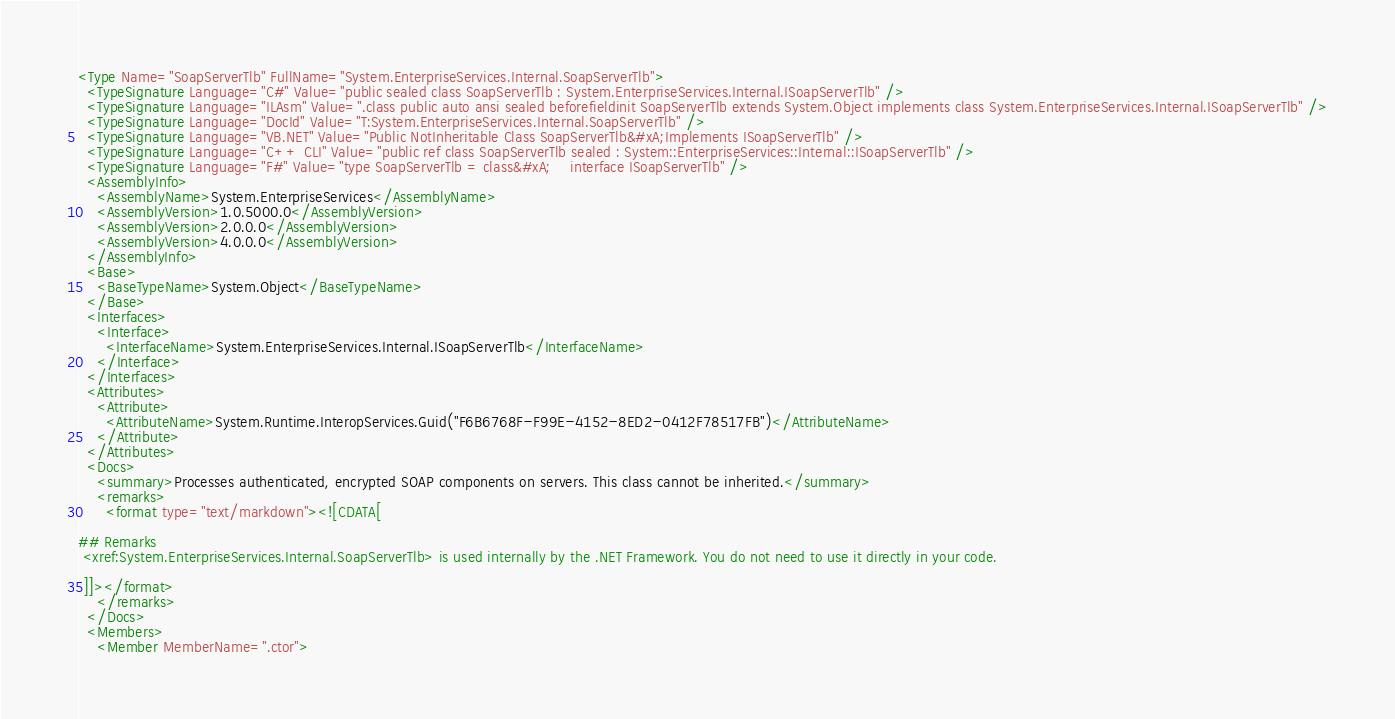<code> <loc_0><loc_0><loc_500><loc_500><_XML_><Type Name="SoapServerTlb" FullName="System.EnterpriseServices.Internal.SoapServerTlb">
  <TypeSignature Language="C#" Value="public sealed class SoapServerTlb : System.EnterpriseServices.Internal.ISoapServerTlb" />
  <TypeSignature Language="ILAsm" Value=".class public auto ansi sealed beforefieldinit SoapServerTlb extends System.Object implements class System.EnterpriseServices.Internal.ISoapServerTlb" />
  <TypeSignature Language="DocId" Value="T:System.EnterpriseServices.Internal.SoapServerTlb" />
  <TypeSignature Language="VB.NET" Value="Public NotInheritable Class SoapServerTlb&#xA;Implements ISoapServerTlb" />
  <TypeSignature Language="C++ CLI" Value="public ref class SoapServerTlb sealed : System::EnterpriseServices::Internal::ISoapServerTlb" />
  <TypeSignature Language="F#" Value="type SoapServerTlb = class&#xA;    interface ISoapServerTlb" />
  <AssemblyInfo>
    <AssemblyName>System.EnterpriseServices</AssemblyName>
    <AssemblyVersion>1.0.5000.0</AssemblyVersion>
    <AssemblyVersion>2.0.0.0</AssemblyVersion>
    <AssemblyVersion>4.0.0.0</AssemblyVersion>
  </AssemblyInfo>
  <Base>
    <BaseTypeName>System.Object</BaseTypeName>
  </Base>
  <Interfaces>
    <Interface>
      <InterfaceName>System.EnterpriseServices.Internal.ISoapServerTlb</InterfaceName>
    </Interface>
  </Interfaces>
  <Attributes>
    <Attribute>
      <AttributeName>System.Runtime.InteropServices.Guid("F6B6768F-F99E-4152-8ED2-0412F78517FB")</AttributeName>
    </Attribute>
  </Attributes>
  <Docs>
    <summary>Processes authenticated, encrypted SOAP components on servers. This class cannot be inherited.</summary>
    <remarks>
      <format type="text/markdown"><![CDATA[  
  
## Remarks  
 <xref:System.EnterpriseServices.Internal.SoapServerTlb> is used internally by the .NET Framework. You do not need to use it directly in your code.  
  
 ]]></format>
    </remarks>
  </Docs>
  <Members>
    <Member MemberName=".ctor"></code> 